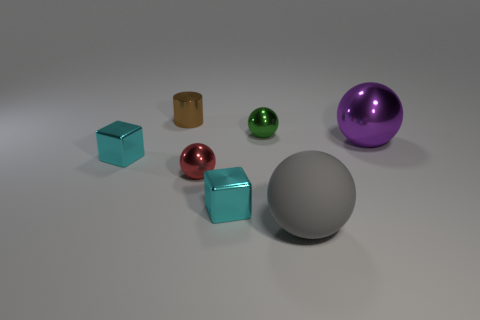How many objects are to the right of the tiny brown shiny cylinder and behind the large rubber ball?
Provide a short and direct response. 4. Is the small red object made of the same material as the large gray object?
Offer a very short reply. No. What shape is the large object that is to the right of the big sphere that is left of the big purple object that is on the right side of the big matte object?
Your answer should be very brief. Sphere. What is the material of the ball that is both behind the small red sphere and left of the large purple sphere?
Your answer should be very brief. Metal. What color is the tiny metallic object right of the metal cube that is on the right side of the cyan metallic object behind the red sphere?
Ensure brevity in your answer.  Green. What number of gray things are either large shiny balls or metallic balls?
Keep it short and to the point. 0. How many other things are there of the same size as the purple sphere?
Offer a terse response. 1. What number of small brown metallic things are there?
Make the answer very short. 1. Is there any other thing that is the same shape as the small brown metallic thing?
Offer a terse response. No. Do the object right of the big rubber thing and the large sphere that is in front of the large shiny ball have the same material?
Provide a short and direct response. No. 